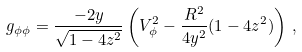<formula> <loc_0><loc_0><loc_500><loc_500>g _ { \phi \phi } = \frac { - 2 y } { \sqrt { 1 - 4 z ^ { 2 } } } \left ( V _ { \phi } ^ { 2 } - \frac { R ^ { 2 } } { 4 y ^ { 2 } } ( 1 - 4 z ^ { 2 } ) \right ) \, ,</formula> 